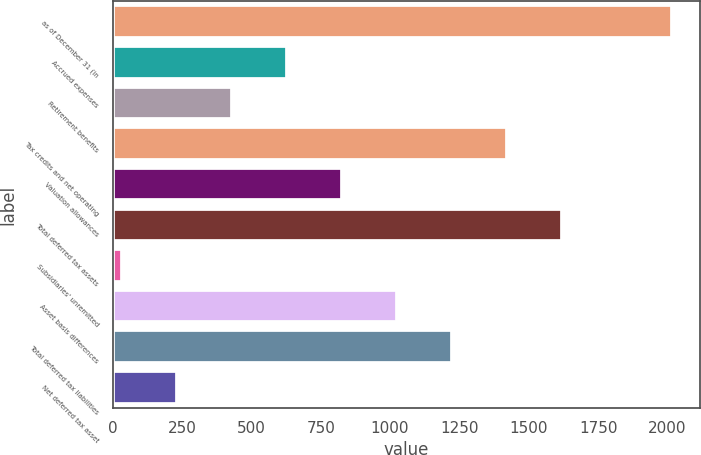<chart> <loc_0><loc_0><loc_500><loc_500><bar_chart><fcel>as of December 31 (in<fcel>Accrued expenses<fcel>Retirement benefits<fcel>Tax credits and net operating<fcel>Valuation allowances<fcel>Total deferred tax assets<fcel>Subsidiaries' unremitted<fcel>Asset basis differences<fcel>Total deferred tax liabilities<fcel>Net deferred tax asset<nl><fcel>2017<fcel>629.6<fcel>431.4<fcel>1422.4<fcel>827.8<fcel>1620.6<fcel>35<fcel>1026<fcel>1224.2<fcel>233.2<nl></chart> 